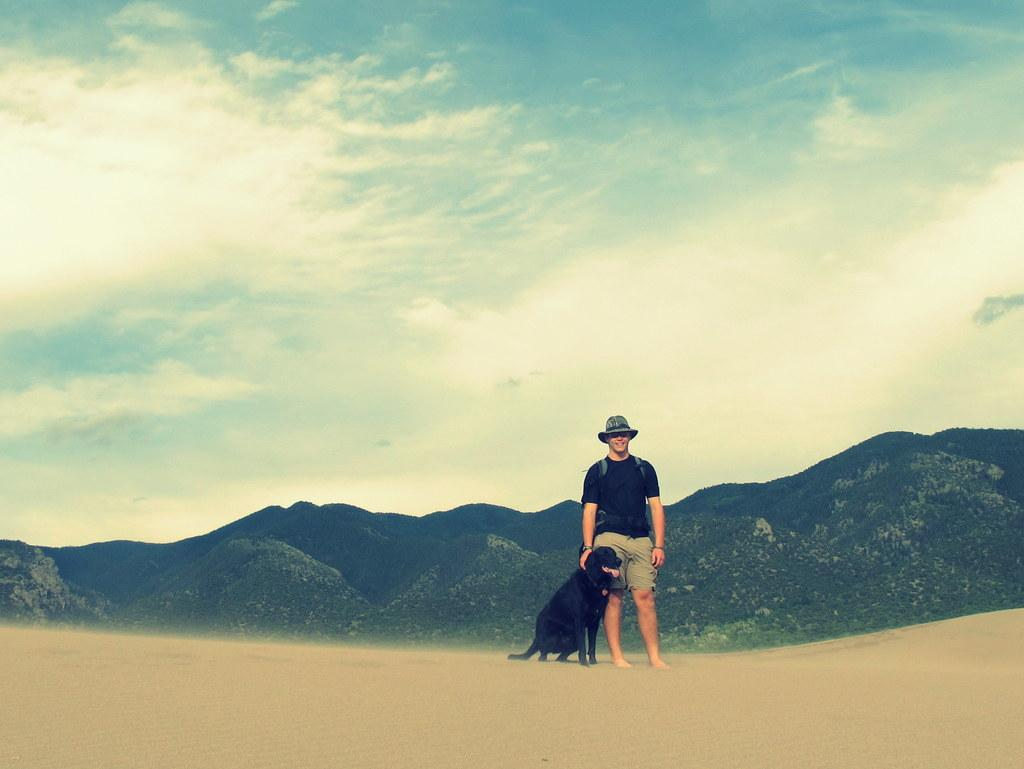What is the main subject of the image? There is a man standing in the image. Where is the man standing? The man is standing on the ground. What animal is beside the man? There is a dog beside the man. What can be seen in the background of the image? There is a group of trees and hills visible in the background. How would you describe the sky in the image? The sky is cloudy in the image. What type of bean is the man holding in his hand in the image? There is no bean present in the image; the man is not holding anything in his hand. 